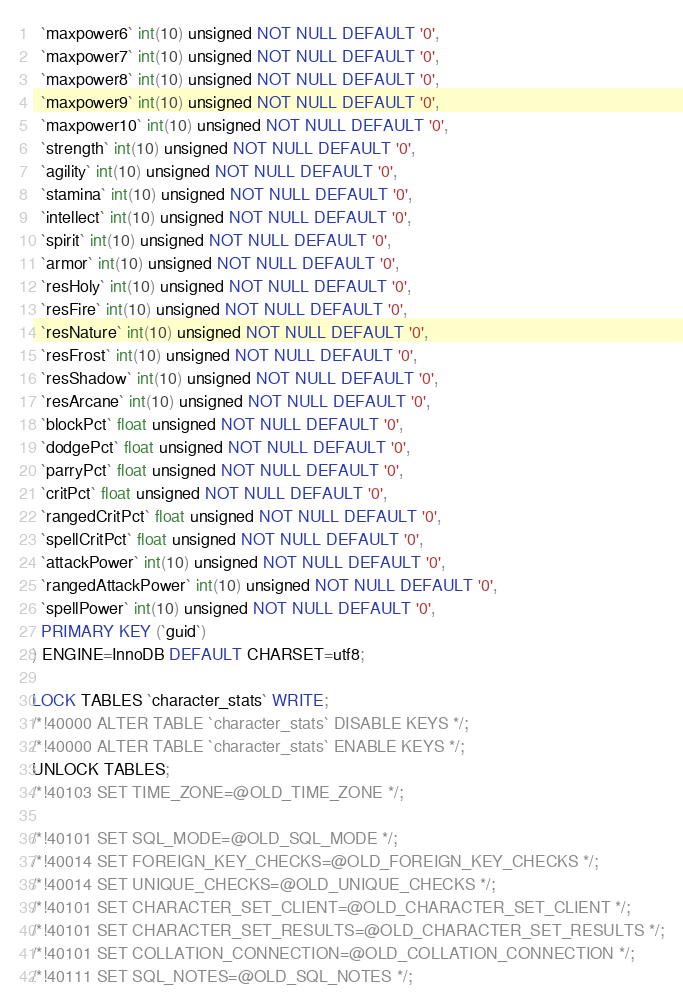Convert code to text. <code><loc_0><loc_0><loc_500><loc_500><_SQL_>  `maxpower6` int(10) unsigned NOT NULL DEFAULT '0',
  `maxpower7` int(10) unsigned NOT NULL DEFAULT '0',
  `maxpower8` int(10) unsigned NOT NULL DEFAULT '0',
  `maxpower9` int(10) unsigned NOT NULL DEFAULT '0',
  `maxpower10` int(10) unsigned NOT NULL DEFAULT '0',
  `strength` int(10) unsigned NOT NULL DEFAULT '0',
  `agility` int(10) unsigned NOT NULL DEFAULT '0',
  `stamina` int(10) unsigned NOT NULL DEFAULT '0',
  `intellect` int(10) unsigned NOT NULL DEFAULT '0',
  `spirit` int(10) unsigned NOT NULL DEFAULT '0',
  `armor` int(10) unsigned NOT NULL DEFAULT '0',
  `resHoly` int(10) unsigned NOT NULL DEFAULT '0',
  `resFire` int(10) unsigned NOT NULL DEFAULT '0',
  `resNature` int(10) unsigned NOT NULL DEFAULT '0',
  `resFrost` int(10) unsigned NOT NULL DEFAULT '0',
  `resShadow` int(10) unsigned NOT NULL DEFAULT '0',
  `resArcane` int(10) unsigned NOT NULL DEFAULT '0',
  `blockPct` float unsigned NOT NULL DEFAULT '0',
  `dodgePct` float unsigned NOT NULL DEFAULT '0',
  `parryPct` float unsigned NOT NULL DEFAULT '0',
  `critPct` float unsigned NOT NULL DEFAULT '0',
  `rangedCritPct` float unsigned NOT NULL DEFAULT '0',
  `spellCritPct` float unsigned NOT NULL DEFAULT '0',
  `attackPower` int(10) unsigned NOT NULL DEFAULT '0',
  `rangedAttackPower` int(10) unsigned NOT NULL DEFAULT '0',
  `spellPower` int(10) unsigned NOT NULL DEFAULT '0',
  PRIMARY KEY (`guid`)
) ENGINE=InnoDB DEFAULT CHARSET=utf8;

LOCK TABLES `character_stats` WRITE;
/*!40000 ALTER TABLE `character_stats` DISABLE KEYS */;
/*!40000 ALTER TABLE `character_stats` ENABLE KEYS */;
UNLOCK TABLES;
/*!40103 SET TIME_ZONE=@OLD_TIME_ZONE */;

/*!40101 SET SQL_MODE=@OLD_SQL_MODE */;
/*!40014 SET FOREIGN_KEY_CHECKS=@OLD_FOREIGN_KEY_CHECKS */;
/*!40014 SET UNIQUE_CHECKS=@OLD_UNIQUE_CHECKS */;
/*!40101 SET CHARACTER_SET_CLIENT=@OLD_CHARACTER_SET_CLIENT */;
/*!40101 SET CHARACTER_SET_RESULTS=@OLD_CHARACTER_SET_RESULTS */;
/*!40101 SET COLLATION_CONNECTION=@OLD_COLLATION_CONNECTION */;
/*!40111 SET SQL_NOTES=@OLD_SQL_NOTES */;

</code> 